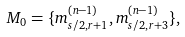<formula> <loc_0><loc_0><loc_500><loc_500>M _ { 0 } = \{ m _ { s / 2 , r + 1 } ^ { ( n - 1 ) } , m _ { s / 2 , r + 3 } ^ { ( n - 1 ) } \} ,</formula> 